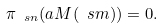Convert formula to latex. <formula><loc_0><loc_0><loc_500><loc_500>\pi _ { \ s n } ( a M ( \ s m ) ) = 0 .</formula> 